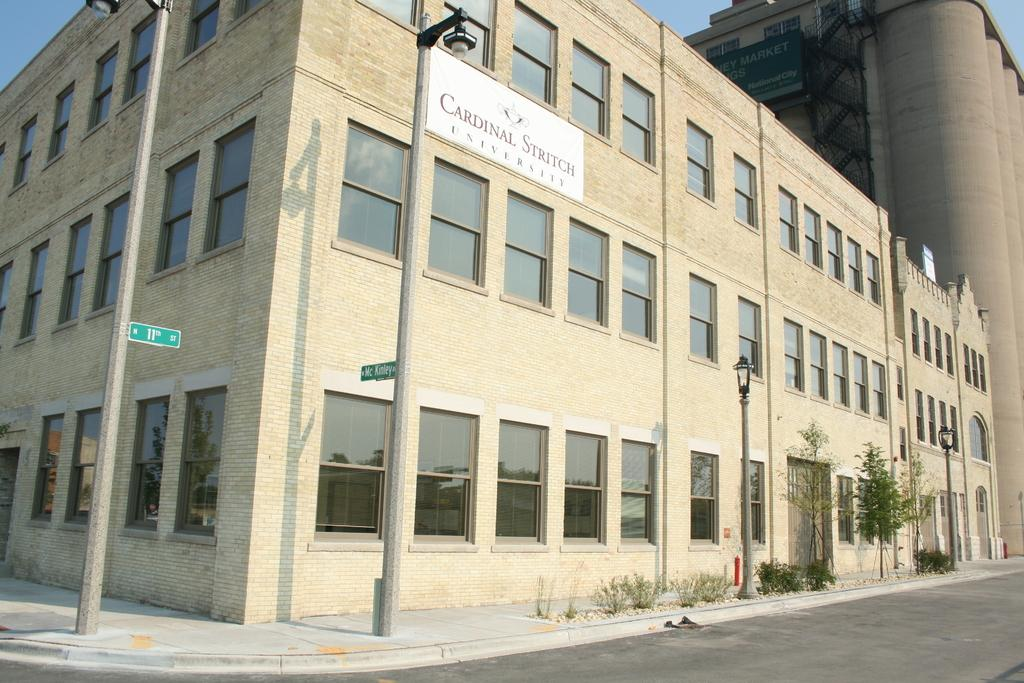What type of structures are on poles in the image? There are lights and boards on poles in the image. What type of vegetation can be seen in the image? There are plants and trees in the image. What type of man-made structures are visible in the image? There are buildings in the image. What part of the natural environment is visible in the image? The sky is visible in the image. What type of pathway is present in the image? There is a road in the image. What is the acoustics rating of the road in the image? The image does not provide information about the acoustics rating of the road. How many cents are visible in the image? There are no cents present in the image. 